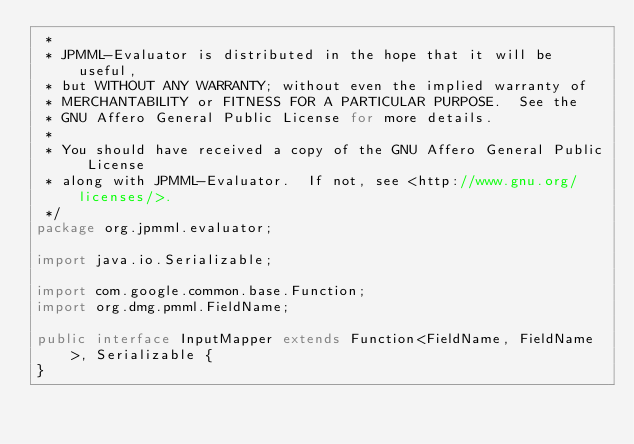<code> <loc_0><loc_0><loc_500><loc_500><_Java_> *
 * JPMML-Evaluator is distributed in the hope that it will be useful,
 * but WITHOUT ANY WARRANTY; without even the implied warranty of
 * MERCHANTABILITY or FITNESS FOR A PARTICULAR PURPOSE.  See the
 * GNU Affero General Public License for more details.
 *
 * You should have received a copy of the GNU Affero General Public License
 * along with JPMML-Evaluator.  If not, see <http://www.gnu.org/licenses/>.
 */
package org.jpmml.evaluator;

import java.io.Serializable;

import com.google.common.base.Function;
import org.dmg.pmml.FieldName;

public interface InputMapper extends Function<FieldName, FieldName>, Serializable {
}</code> 